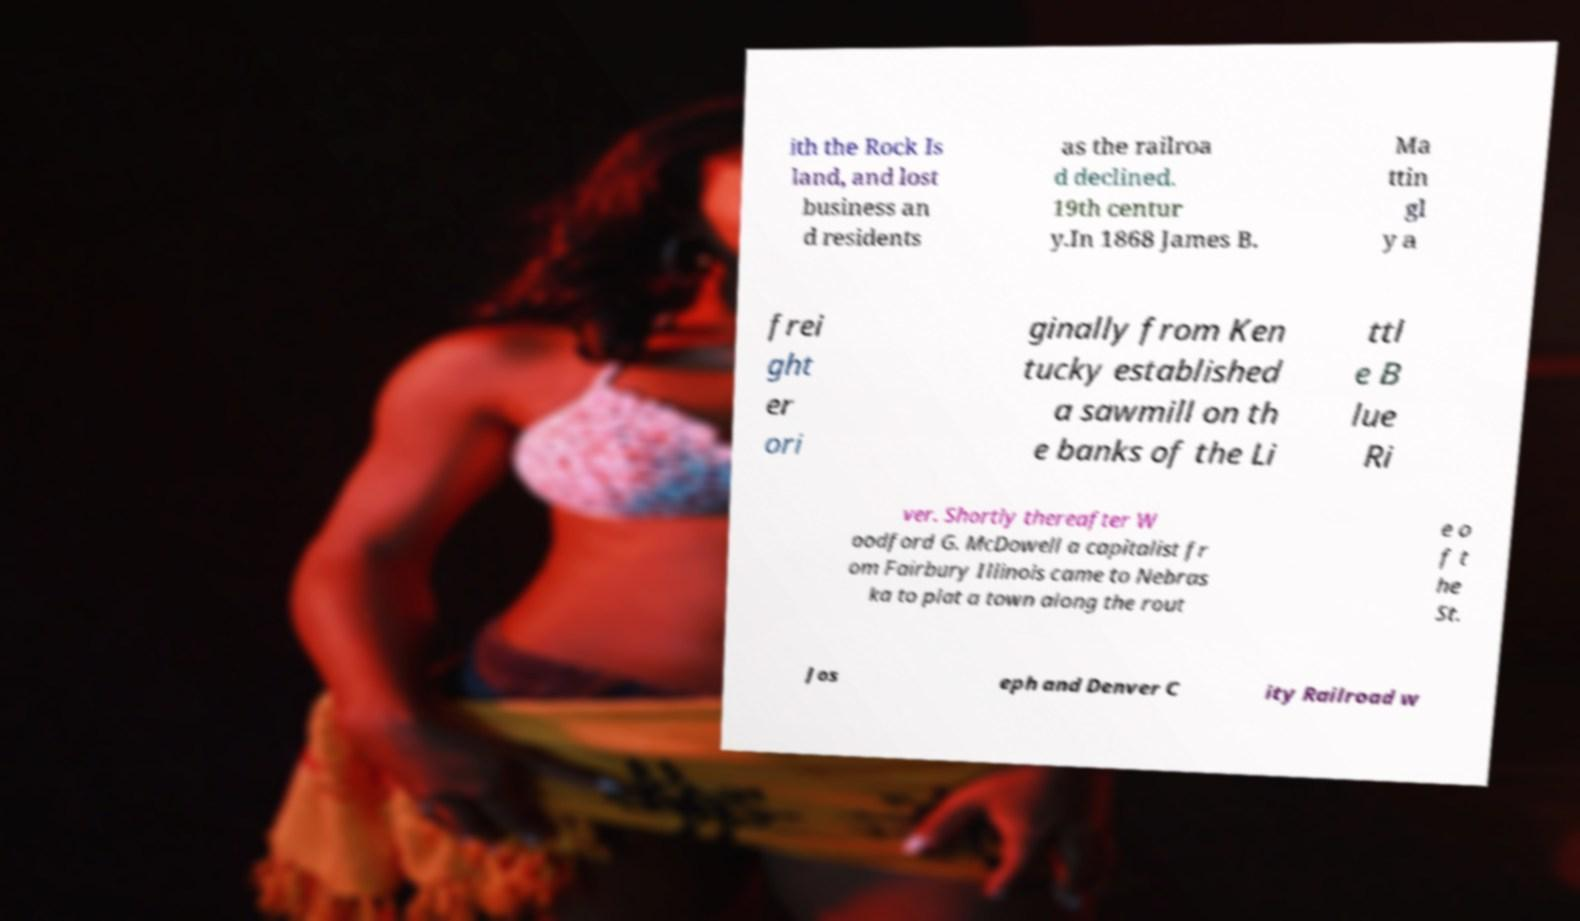For documentation purposes, I need the text within this image transcribed. Could you provide that? ith the Rock Is land, and lost business an d residents as the railroa d declined. 19th centur y.In 1868 James B. Ma ttin gl y a frei ght er ori ginally from Ken tucky established a sawmill on th e banks of the Li ttl e B lue Ri ver. Shortly thereafter W oodford G. McDowell a capitalist fr om Fairbury Illinois came to Nebras ka to plat a town along the rout e o f t he St. Jos eph and Denver C ity Railroad w 